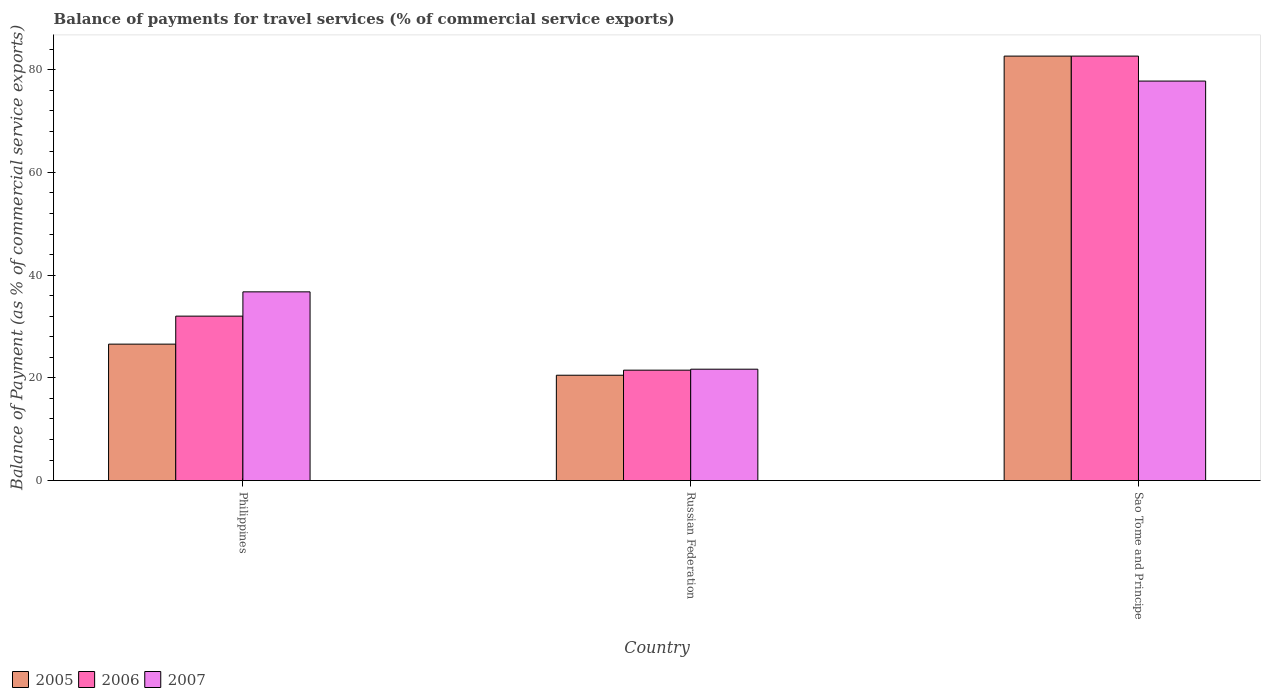Are the number of bars per tick equal to the number of legend labels?
Ensure brevity in your answer.  Yes. How many bars are there on the 1st tick from the right?
Keep it short and to the point. 3. What is the label of the 2nd group of bars from the left?
Your answer should be compact. Russian Federation. In how many cases, is the number of bars for a given country not equal to the number of legend labels?
Offer a very short reply. 0. What is the balance of payments for travel services in 2006 in Russian Federation?
Provide a succinct answer. 21.5. Across all countries, what is the maximum balance of payments for travel services in 2007?
Your response must be concise. 77.78. Across all countries, what is the minimum balance of payments for travel services in 2006?
Your response must be concise. 21.5. In which country was the balance of payments for travel services in 2005 maximum?
Offer a very short reply. Sao Tome and Principe. In which country was the balance of payments for travel services in 2005 minimum?
Your answer should be very brief. Russian Federation. What is the total balance of payments for travel services in 2007 in the graph?
Your answer should be very brief. 136.21. What is the difference between the balance of payments for travel services in 2006 in Philippines and that in Sao Tome and Principe?
Your answer should be compact. -50.63. What is the difference between the balance of payments for travel services in 2006 in Philippines and the balance of payments for travel services in 2005 in Russian Federation?
Make the answer very short. 11.5. What is the average balance of payments for travel services in 2007 per country?
Offer a terse response. 45.4. What is the difference between the balance of payments for travel services of/in 2005 and balance of payments for travel services of/in 2007 in Sao Tome and Principe?
Make the answer very short. 4.86. In how many countries, is the balance of payments for travel services in 2005 greater than 32 %?
Keep it short and to the point. 1. What is the ratio of the balance of payments for travel services in 2005 in Philippines to that in Russian Federation?
Offer a terse response. 1.3. Is the balance of payments for travel services in 2006 in Russian Federation less than that in Sao Tome and Principe?
Offer a very short reply. Yes. What is the difference between the highest and the second highest balance of payments for travel services in 2006?
Offer a terse response. -50.63. What is the difference between the highest and the lowest balance of payments for travel services in 2006?
Offer a terse response. 61.15. What does the 1st bar from the left in Philippines represents?
Make the answer very short. 2005. Is it the case that in every country, the sum of the balance of payments for travel services in 2005 and balance of payments for travel services in 2007 is greater than the balance of payments for travel services in 2006?
Provide a short and direct response. Yes. How many bars are there?
Give a very brief answer. 9. What is the difference between two consecutive major ticks on the Y-axis?
Offer a very short reply. 20. How many legend labels are there?
Give a very brief answer. 3. How are the legend labels stacked?
Ensure brevity in your answer.  Horizontal. What is the title of the graph?
Ensure brevity in your answer.  Balance of payments for travel services (% of commercial service exports). What is the label or title of the X-axis?
Provide a short and direct response. Country. What is the label or title of the Y-axis?
Provide a succinct answer. Balance of Payment (as % of commercial service exports). What is the Balance of Payment (as % of commercial service exports) in 2005 in Philippines?
Keep it short and to the point. 26.56. What is the Balance of Payment (as % of commercial service exports) of 2006 in Philippines?
Your answer should be compact. 32.02. What is the Balance of Payment (as % of commercial service exports) of 2007 in Philippines?
Ensure brevity in your answer.  36.74. What is the Balance of Payment (as % of commercial service exports) of 2005 in Russian Federation?
Ensure brevity in your answer.  20.51. What is the Balance of Payment (as % of commercial service exports) in 2006 in Russian Federation?
Ensure brevity in your answer.  21.5. What is the Balance of Payment (as % of commercial service exports) of 2007 in Russian Federation?
Provide a succinct answer. 21.69. What is the Balance of Payment (as % of commercial service exports) of 2005 in Sao Tome and Principe?
Ensure brevity in your answer.  82.64. What is the Balance of Payment (as % of commercial service exports) in 2006 in Sao Tome and Principe?
Your answer should be compact. 82.64. What is the Balance of Payment (as % of commercial service exports) in 2007 in Sao Tome and Principe?
Offer a terse response. 77.78. Across all countries, what is the maximum Balance of Payment (as % of commercial service exports) in 2005?
Your answer should be compact. 82.64. Across all countries, what is the maximum Balance of Payment (as % of commercial service exports) of 2006?
Make the answer very short. 82.64. Across all countries, what is the maximum Balance of Payment (as % of commercial service exports) of 2007?
Provide a short and direct response. 77.78. Across all countries, what is the minimum Balance of Payment (as % of commercial service exports) in 2005?
Offer a very short reply. 20.51. Across all countries, what is the minimum Balance of Payment (as % of commercial service exports) of 2006?
Keep it short and to the point. 21.5. Across all countries, what is the minimum Balance of Payment (as % of commercial service exports) in 2007?
Give a very brief answer. 21.69. What is the total Balance of Payment (as % of commercial service exports) of 2005 in the graph?
Ensure brevity in your answer.  129.72. What is the total Balance of Payment (as % of commercial service exports) of 2006 in the graph?
Provide a succinct answer. 136.16. What is the total Balance of Payment (as % of commercial service exports) of 2007 in the graph?
Offer a terse response. 136.21. What is the difference between the Balance of Payment (as % of commercial service exports) in 2005 in Philippines and that in Russian Federation?
Give a very brief answer. 6.05. What is the difference between the Balance of Payment (as % of commercial service exports) in 2006 in Philippines and that in Russian Federation?
Give a very brief answer. 10.52. What is the difference between the Balance of Payment (as % of commercial service exports) in 2007 in Philippines and that in Russian Federation?
Your response must be concise. 15.06. What is the difference between the Balance of Payment (as % of commercial service exports) of 2005 in Philippines and that in Sao Tome and Principe?
Give a very brief answer. -56.08. What is the difference between the Balance of Payment (as % of commercial service exports) in 2006 in Philippines and that in Sao Tome and Principe?
Offer a terse response. -50.63. What is the difference between the Balance of Payment (as % of commercial service exports) in 2007 in Philippines and that in Sao Tome and Principe?
Your answer should be very brief. -41.04. What is the difference between the Balance of Payment (as % of commercial service exports) in 2005 in Russian Federation and that in Sao Tome and Principe?
Offer a terse response. -62.13. What is the difference between the Balance of Payment (as % of commercial service exports) of 2006 in Russian Federation and that in Sao Tome and Principe?
Your response must be concise. -61.15. What is the difference between the Balance of Payment (as % of commercial service exports) of 2007 in Russian Federation and that in Sao Tome and Principe?
Provide a succinct answer. -56.1. What is the difference between the Balance of Payment (as % of commercial service exports) in 2005 in Philippines and the Balance of Payment (as % of commercial service exports) in 2006 in Russian Federation?
Keep it short and to the point. 5.07. What is the difference between the Balance of Payment (as % of commercial service exports) of 2005 in Philippines and the Balance of Payment (as % of commercial service exports) of 2007 in Russian Federation?
Make the answer very short. 4.88. What is the difference between the Balance of Payment (as % of commercial service exports) of 2006 in Philippines and the Balance of Payment (as % of commercial service exports) of 2007 in Russian Federation?
Make the answer very short. 10.33. What is the difference between the Balance of Payment (as % of commercial service exports) of 2005 in Philippines and the Balance of Payment (as % of commercial service exports) of 2006 in Sao Tome and Principe?
Your answer should be compact. -56.08. What is the difference between the Balance of Payment (as % of commercial service exports) of 2005 in Philippines and the Balance of Payment (as % of commercial service exports) of 2007 in Sao Tome and Principe?
Give a very brief answer. -51.22. What is the difference between the Balance of Payment (as % of commercial service exports) in 2006 in Philippines and the Balance of Payment (as % of commercial service exports) in 2007 in Sao Tome and Principe?
Your answer should be compact. -45.77. What is the difference between the Balance of Payment (as % of commercial service exports) of 2005 in Russian Federation and the Balance of Payment (as % of commercial service exports) of 2006 in Sao Tome and Principe?
Provide a succinct answer. -62.13. What is the difference between the Balance of Payment (as % of commercial service exports) of 2005 in Russian Federation and the Balance of Payment (as % of commercial service exports) of 2007 in Sao Tome and Principe?
Give a very brief answer. -57.27. What is the difference between the Balance of Payment (as % of commercial service exports) of 2006 in Russian Federation and the Balance of Payment (as % of commercial service exports) of 2007 in Sao Tome and Principe?
Provide a succinct answer. -56.29. What is the average Balance of Payment (as % of commercial service exports) of 2005 per country?
Provide a succinct answer. 43.24. What is the average Balance of Payment (as % of commercial service exports) of 2006 per country?
Provide a succinct answer. 45.39. What is the average Balance of Payment (as % of commercial service exports) in 2007 per country?
Provide a succinct answer. 45.4. What is the difference between the Balance of Payment (as % of commercial service exports) in 2005 and Balance of Payment (as % of commercial service exports) in 2006 in Philippines?
Your answer should be very brief. -5.45. What is the difference between the Balance of Payment (as % of commercial service exports) of 2005 and Balance of Payment (as % of commercial service exports) of 2007 in Philippines?
Your response must be concise. -10.18. What is the difference between the Balance of Payment (as % of commercial service exports) in 2006 and Balance of Payment (as % of commercial service exports) in 2007 in Philippines?
Your answer should be very brief. -4.73. What is the difference between the Balance of Payment (as % of commercial service exports) in 2005 and Balance of Payment (as % of commercial service exports) in 2006 in Russian Federation?
Your response must be concise. -0.99. What is the difference between the Balance of Payment (as % of commercial service exports) of 2005 and Balance of Payment (as % of commercial service exports) of 2007 in Russian Federation?
Ensure brevity in your answer.  -1.17. What is the difference between the Balance of Payment (as % of commercial service exports) of 2006 and Balance of Payment (as % of commercial service exports) of 2007 in Russian Federation?
Offer a terse response. -0.19. What is the difference between the Balance of Payment (as % of commercial service exports) in 2005 and Balance of Payment (as % of commercial service exports) in 2006 in Sao Tome and Principe?
Offer a terse response. -0. What is the difference between the Balance of Payment (as % of commercial service exports) in 2005 and Balance of Payment (as % of commercial service exports) in 2007 in Sao Tome and Principe?
Your answer should be very brief. 4.86. What is the difference between the Balance of Payment (as % of commercial service exports) in 2006 and Balance of Payment (as % of commercial service exports) in 2007 in Sao Tome and Principe?
Make the answer very short. 4.86. What is the ratio of the Balance of Payment (as % of commercial service exports) of 2005 in Philippines to that in Russian Federation?
Give a very brief answer. 1.3. What is the ratio of the Balance of Payment (as % of commercial service exports) of 2006 in Philippines to that in Russian Federation?
Make the answer very short. 1.49. What is the ratio of the Balance of Payment (as % of commercial service exports) in 2007 in Philippines to that in Russian Federation?
Offer a very short reply. 1.69. What is the ratio of the Balance of Payment (as % of commercial service exports) in 2005 in Philippines to that in Sao Tome and Principe?
Your answer should be compact. 0.32. What is the ratio of the Balance of Payment (as % of commercial service exports) in 2006 in Philippines to that in Sao Tome and Principe?
Give a very brief answer. 0.39. What is the ratio of the Balance of Payment (as % of commercial service exports) in 2007 in Philippines to that in Sao Tome and Principe?
Your answer should be compact. 0.47. What is the ratio of the Balance of Payment (as % of commercial service exports) in 2005 in Russian Federation to that in Sao Tome and Principe?
Offer a terse response. 0.25. What is the ratio of the Balance of Payment (as % of commercial service exports) of 2006 in Russian Federation to that in Sao Tome and Principe?
Ensure brevity in your answer.  0.26. What is the ratio of the Balance of Payment (as % of commercial service exports) in 2007 in Russian Federation to that in Sao Tome and Principe?
Make the answer very short. 0.28. What is the difference between the highest and the second highest Balance of Payment (as % of commercial service exports) in 2005?
Provide a short and direct response. 56.08. What is the difference between the highest and the second highest Balance of Payment (as % of commercial service exports) in 2006?
Provide a succinct answer. 50.63. What is the difference between the highest and the second highest Balance of Payment (as % of commercial service exports) of 2007?
Offer a very short reply. 41.04. What is the difference between the highest and the lowest Balance of Payment (as % of commercial service exports) of 2005?
Your answer should be very brief. 62.13. What is the difference between the highest and the lowest Balance of Payment (as % of commercial service exports) of 2006?
Keep it short and to the point. 61.15. What is the difference between the highest and the lowest Balance of Payment (as % of commercial service exports) of 2007?
Offer a very short reply. 56.1. 